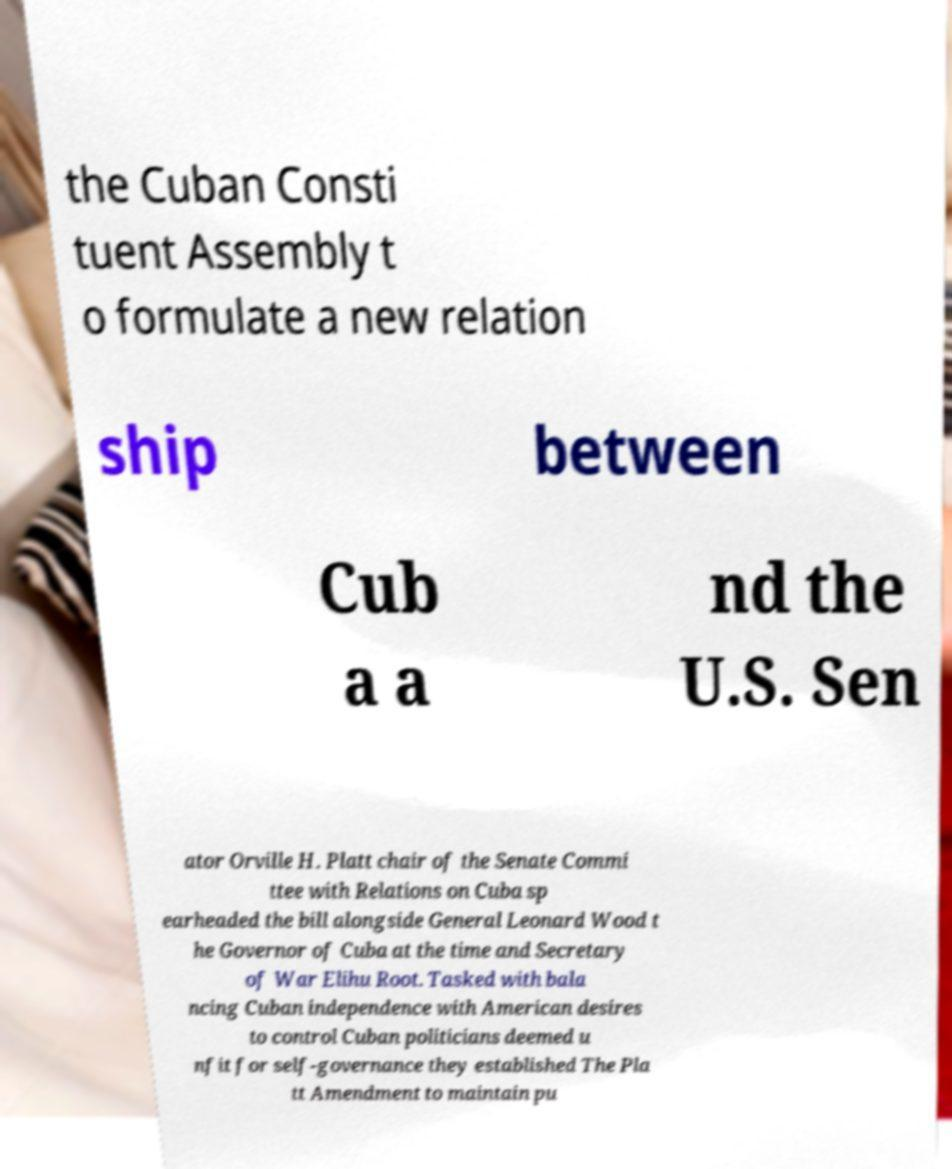For documentation purposes, I need the text within this image transcribed. Could you provide that? the Cuban Consti tuent Assembly t o formulate a new relation ship between Cub a a nd the U.S. Sen ator Orville H. Platt chair of the Senate Commi ttee with Relations on Cuba sp earheaded the bill alongside General Leonard Wood t he Governor of Cuba at the time and Secretary of War Elihu Root. Tasked with bala ncing Cuban independence with American desires to control Cuban politicians deemed u nfit for self-governance they established The Pla tt Amendment to maintain pu 